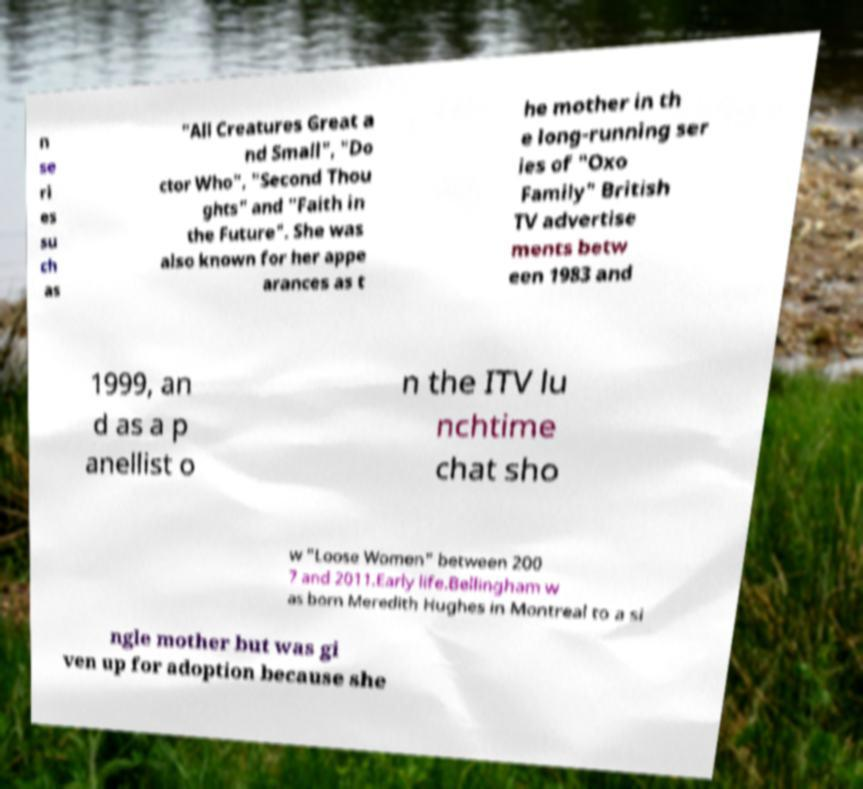Could you assist in decoding the text presented in this image and type it out clearly? n se ri es su ch as "All Creatures Great a nd Small", "Do ctor Who", "Second Thou ghts" and "Faith in the Future". She was also known for her appe arances as t he mother in th e long-running ser ies of "Oxo Family" British TV advertise ments betw een 1983 and 1999, an d as a p anellist o n the ITV lu nchtime chat sho w "Loose Women" between 200 7 and 2011.Early life.Bellingham w as born Meredith Hughes in Montreal to a si ngle mother but was gi ven up for adoption because she 